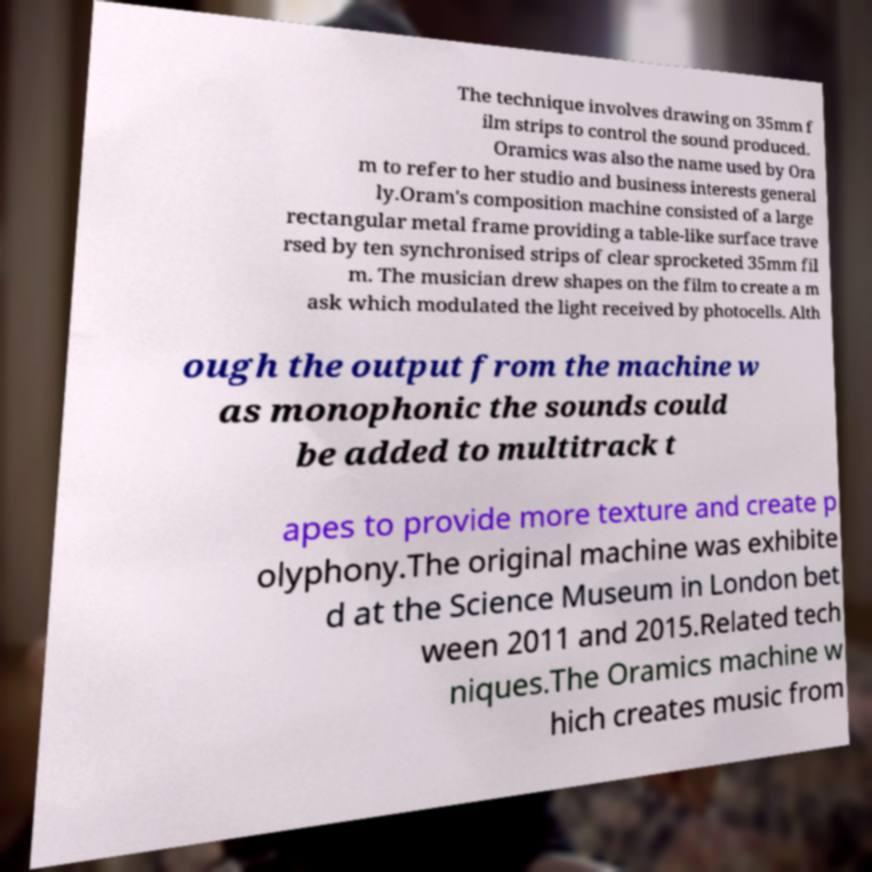Can you accurately transcribe the text from the provided image for me? The technique involves drawing on 35mm f ilm strips to control the sound produced. Oramics was also the name used by Ora m to refer to her studio and business interests general ly.Oram's composition machine consisted of a large rectangular metal frame providing a table-like surface trave rsed by ten synchronised strips of clear sprocketed 35mm fil m. The musician drew shapes on the film to create a m ask which modulated the light received by photocells. Alth ough the output from the machine w as monophonic the sounds could be added to multitrack t apes to provide more texture and create p olyphony.The original machine was exhibite d at the Science Museum in London bet ween 2011 and 2015.Related tech niques.The Oramics machine w hich creates music from 